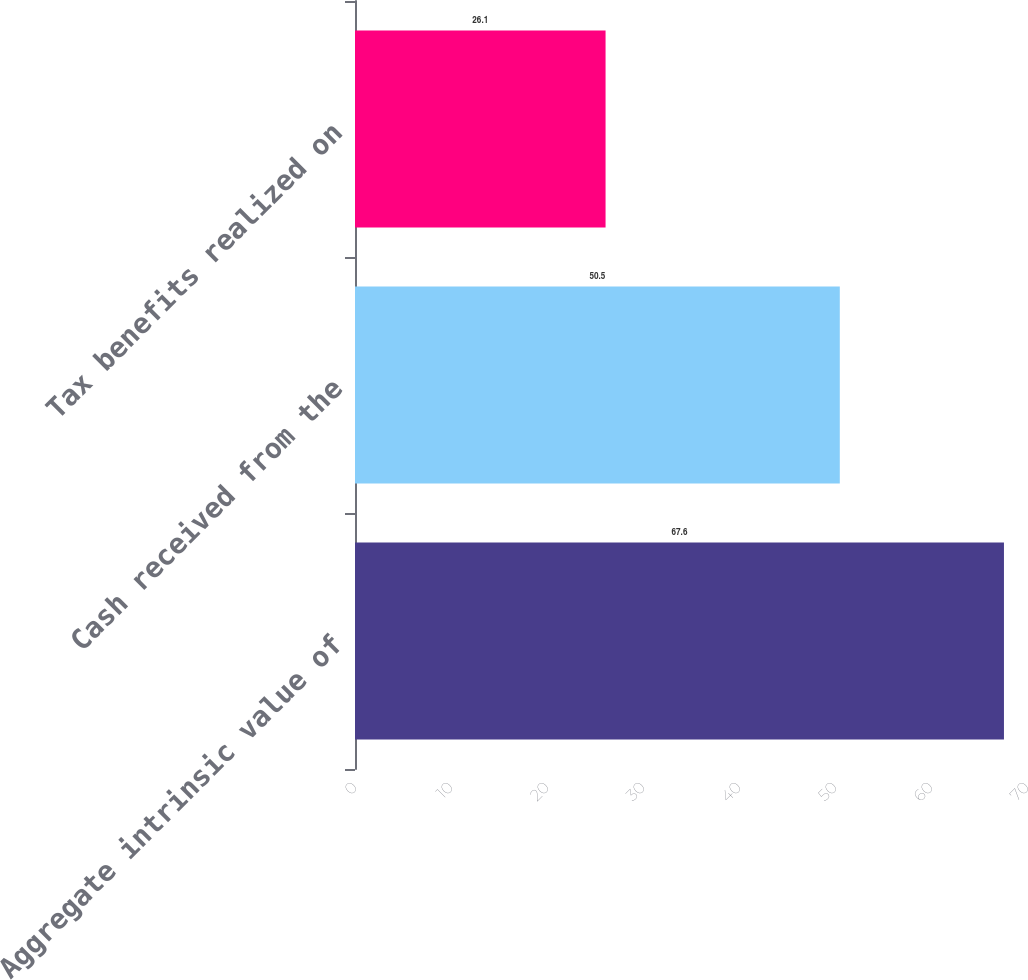<chart> <loc_0><loc_0><loc_500><loc_500><bar_chart><fcel>Aggregate intrinsic value of<fcel>Cash received from the<fcel>Tax benefits realized on<nl><fcel>67.6<fcel>50.5<fcel>26.1<nl></chart> 